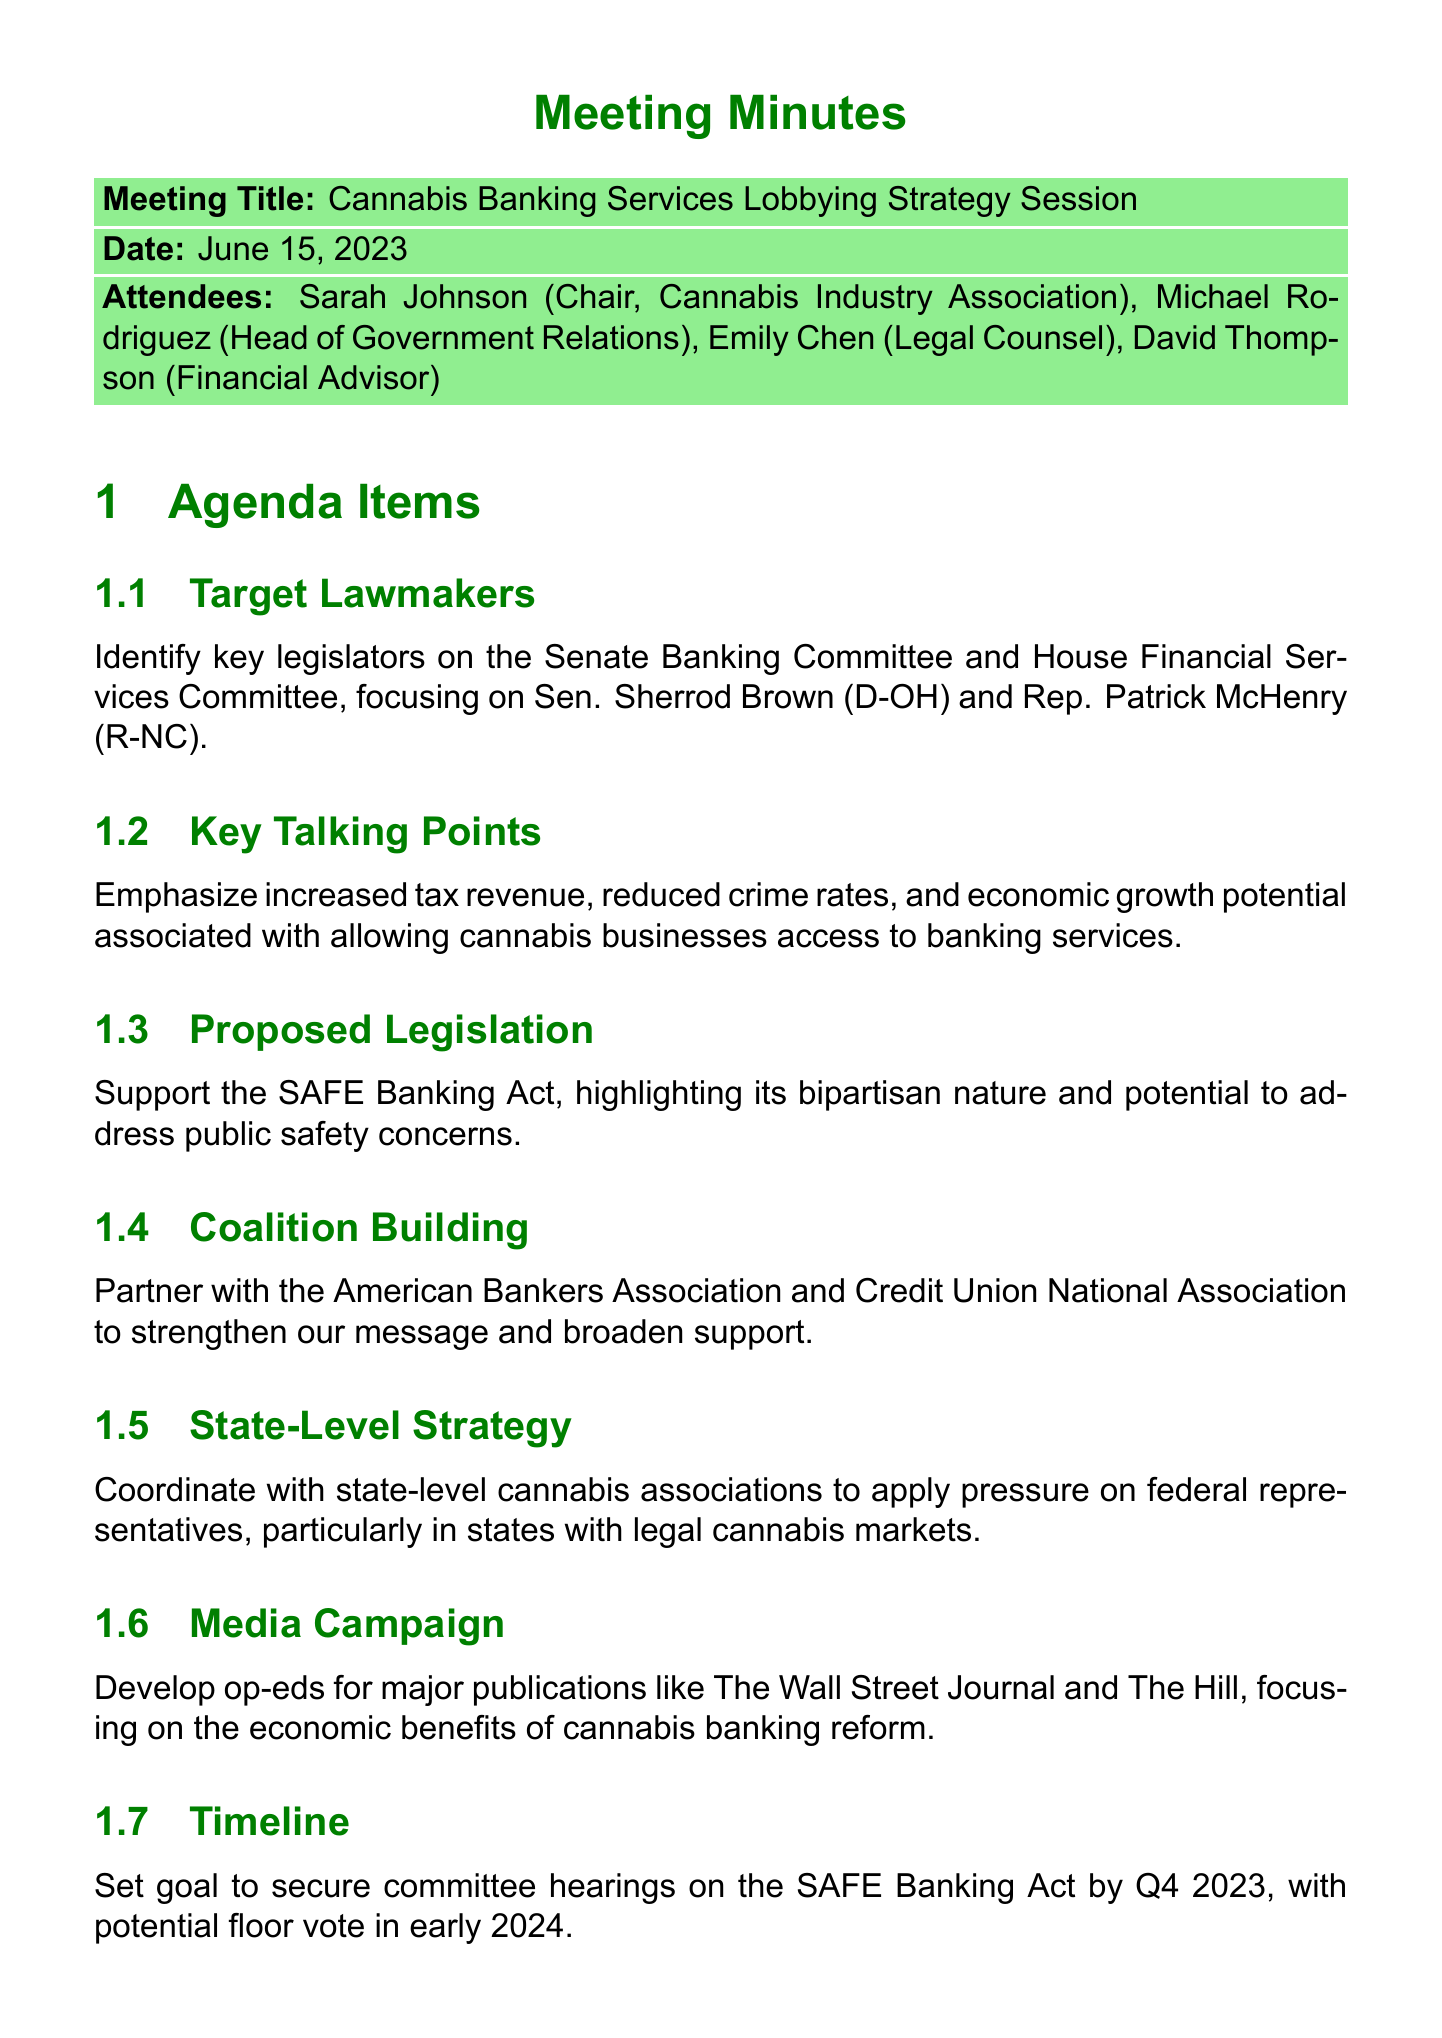What is the date of the meeting? The meeting is dated June 15, 2023, as listed in the document.
Answer: June 15, 2023 Who is the Chair of the meeting? Sarah Johnson is mentioned as the Chair of the Cannabis Industry Association in the attendee list.
Answer: Sarah Johnson Which two lawmakers were specifically focused on in the strategy session? The document specifies focusing on Sen. Sherrod Brown (D-OH) and Rep. Patrick McHenry (R-NC) as key legislators.
Answer: Sen. Sherrod Brown (D-OH) and Rep. Patrick McHenry (R-NC) What is the primary proposed legislation discussed? The SAFE Banking Act is identified as the primary proposed legislation in the meeting agenda.
Answer: SAFE Banking Act What is one of the highlights of the media campaign strategy? The media campaign focuses on developing op-eds for major publications like The Wall Street Journal and The Hill.
Answer: Op-eds for major publications How many action items were assigned during the meeting? There are four action items detailed in the document.
Answer: Four What is the goal timeline set for committee hearings on the SAFE Banking Act? The goal is to secure committee hearings by Q4 2023, as outlined in the timeline section.
Answer: Q4 2023 Which organizations are suggested for coalition building? The document mentions partnering with the American Bankers Association and Credit Union National Association.
Answer: American Bankers Association and Credit Union National Association What type of points are emphasized regarding cannabis businesses? Economic growth potential and tax revenue are emphasized as key talking points associated with cannabis banking services.
Answer: Economic growth potential and tax revenue 